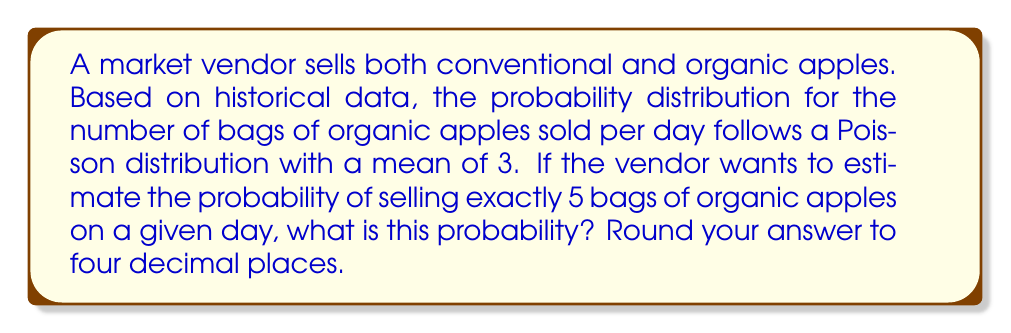Teach me how to tackle this problem. To solve this problem, we'll use the Poisson probability mass function. The Poisson distribution is a discrete probability distribution that expresses the probability of a given number of events occurring in a fixed interval of time or space if these events occur with a known constant mean rate and independently of the time since the last event.

The Poisson probability mass function is given by:

$$P(X = k) = \frac{e^{-\lambda} \lambda^k}{k!}$$

Where:
- $\lambda$ is the average number of events per interval
- $k$ is the number of events we're interested in
- $e$ is Euler's number (approximately 2.71828)

In this case:
- $\lambda = 3$ (mean number of bags sold per day)
- $k = 5$ (we're interested in the probability of selling exactly 5 bags)

Let's plug these values into the formula:

$$P(X = 5) = \frac{e^{-3} 3^5}{5!}$$

Now, let's calculate step by step:

1) First, calculate $e^{-3}$:
   $e^{-3} \approx 0.0497870684$

2) Calculate $3^5$:
   $3^5 = 243$

3) Calculate $5!$:
   $5! = 5 \times 4 \times 3 \times 2 \times 1 = 120$

4) Now, put it all together:
   $$\frac{0.0497870684 \times 243}{120} \approx 0.1008$$

5) Rounding to four decimal places:
   $0.1008$

Therefore, the probability of selling exactly 5 bags of organic apples on a given day is approximately 0.1008 or 10.08%.
Answer: 0.1008 